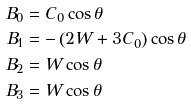Convert formula to latex. <formula><loc_0><loc_0><loc_500><loc_500>B _ { 0 } & = C _ { 0 } \cos \theta \\ B _ { 1 } & = - \left ( 2 W + 3 C _ { 0 } \right ) \cos \theta \\ B _ { 2 } & = W \cos \theta \\ B _ { 3 } & = W \cos \theta</formula> 